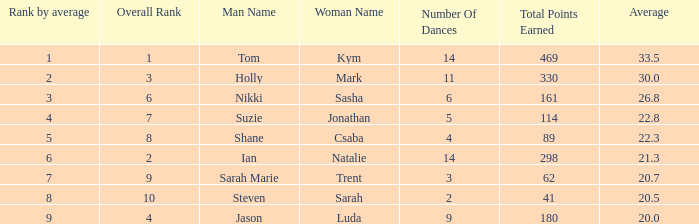What is the name of the couple if the total points earned is 161? Nikki & Sasha. 